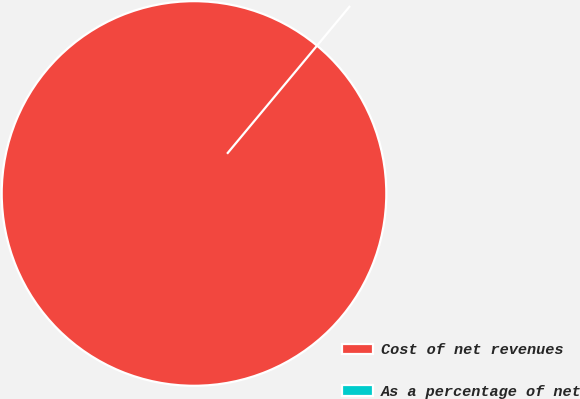<chart> <loc_0><loc_0><loc_500><loc_500><pie_chart><fcel>Cost of net revenues<fcel>As a percentage of net<nl><fcel>100.0%<fcel>0.0%<nl></chart> 